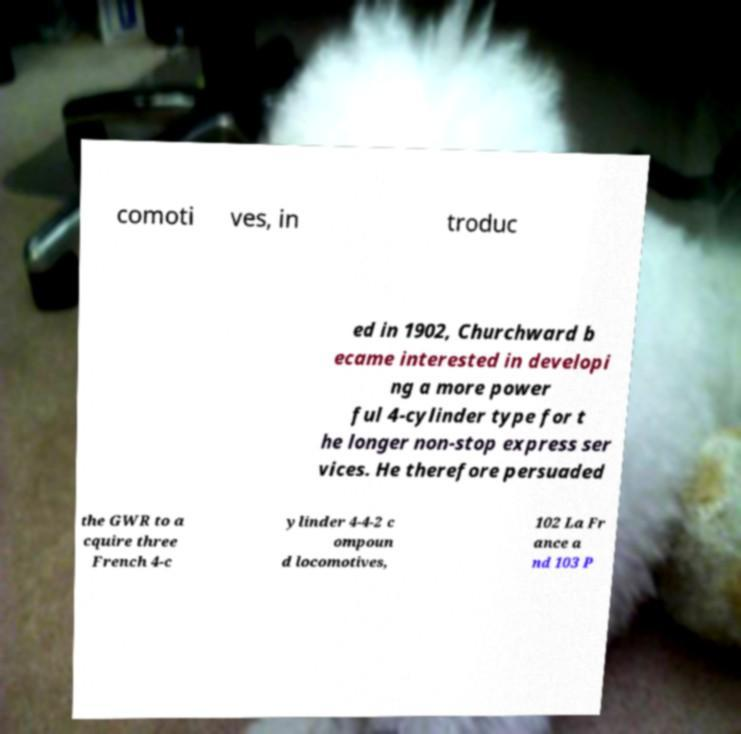What messages or text are displayed in this image? I need them in a readable, typed format. comoti ves, in troduc ed in 1902, Churchward b ecame interested in developi ng a more power ful 4-cylinder type for t he longer non-stop express ser vices. He therefore persuaded the GWR to a cquire three French 4-c ylinder 4-4-2 c ompoun d locomotives, 102 La Fr ance a nd 103 P 